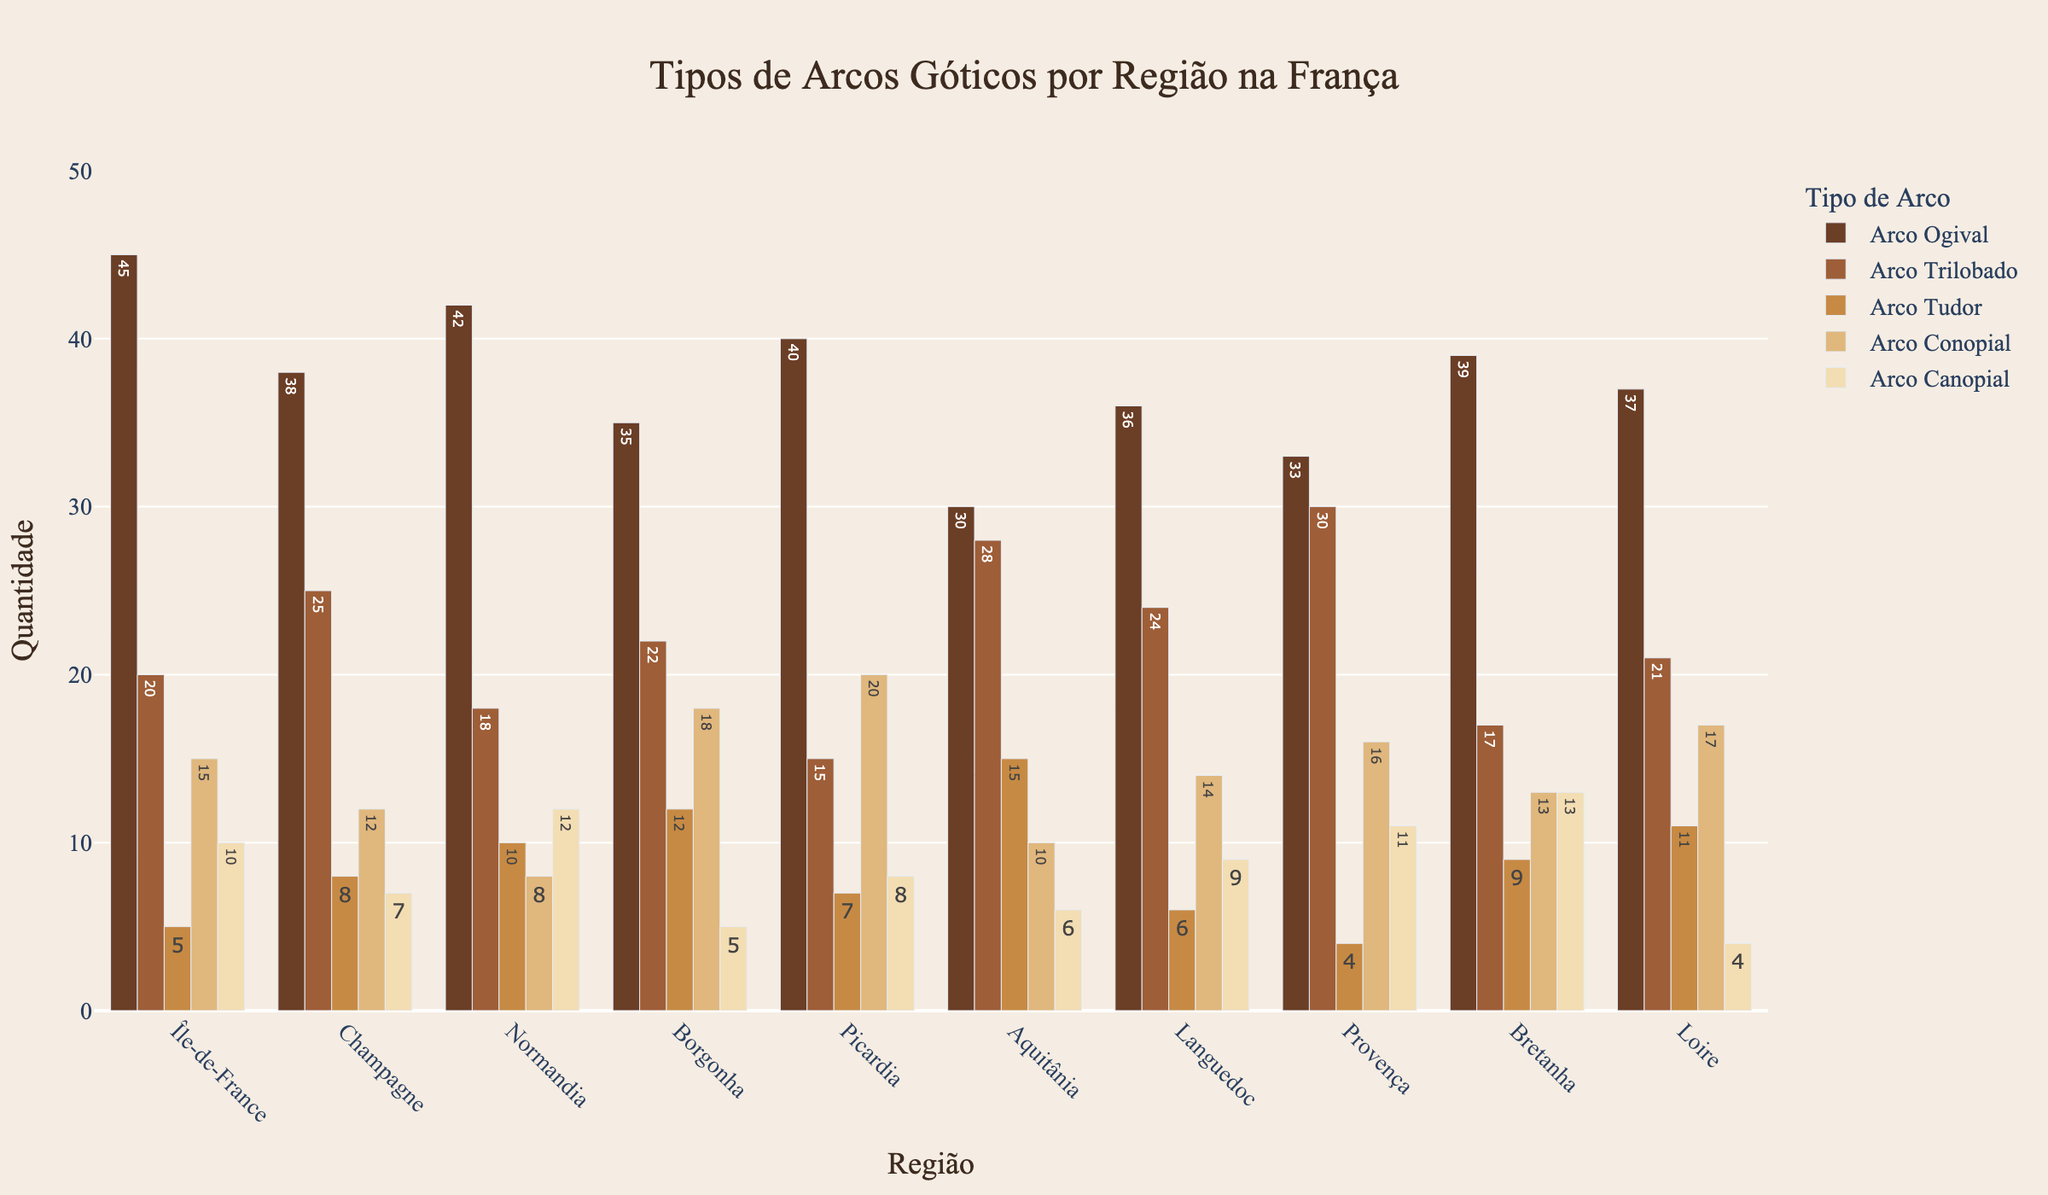Which region has the highest number of Arco Ogival? The bar chart clearly shows the Arco Ogival counts for each region. Île-de-France has the tallest bar for Arco Ogival.
Answer: Île-de-France What is the total number of Arco Canopial used in Champagne and Borgonha? Look at the height of the bars representing Arco Canopial for Champagne and Borgonha and sum their values: 7 (Champagne) + 5 (Borgonha) = 12.
Answer: 12 Which region has more Arco Trilobado, Aquitânia or Provença? Compare the heights of the Arco Trilobado bars for Aquitânia and Provença. Provença's bar is taller than Aquitânia's.
Answer: Provença How many more Arco Tudor are there in Normandia compared to Île-de-France? Subtract the value of Arco Tudor in Île-de-France from that in Normandia: 10 (Normandia) - 5 (Île-de-France) = 5.
Answer: 5 Which type of Gothic arch is most commonly used in Languedoc? Languedoc has different bar heights for each arch type. The tallest bar corresponds to Arco Trilobado.
Answer: Arco Trilobado What is the average number of Arco Conopial in Picardia, Aquitânia, and Bretanha? Sum the values of Arco Conopial for Picardia, Aquitânia, and Bretanha: 20 + 10 + 13 = 43. Divide by 3 to find the average: 43/3 ≈ 14.3.
Answer: 14.3 Which region has the lowest number of Arco Tudor? The shortest bar for Arco Tudor indicates the region with the fewest. Provença has the shortest bar for Arco Tudor.
Answer: Provença Are there more Arco Canopial in Normandia or in Provença? Compare the bars representing Arco Canopial for both regions. Normandia has a taller bar than Provença.
Answer: Normandia What is the total number of Arco Ogival used in all regions combined? Sum the values of Arco Ogival for all regions: 45 (Île-de-France) + 38 (Champagne) + 42 (Normandia) + 35 (Borgonha) + 40 (Picardia) + 30 (Aquitânia) + 36 (Languedoc) + 33 (Provença) + 39 (Bretanha) + 37 (Loire) = 375.
Answer: 375 Which region has the highest combined total of all types of Gothic arches? Add the values of all arch types for each region. Île-de-France = 45+20+5+15+10 = 95, Champagne = 38+25+8+12+7 = 90, and so forth. Île-de-France has the highest total sum.
Answer: Île-de-France 